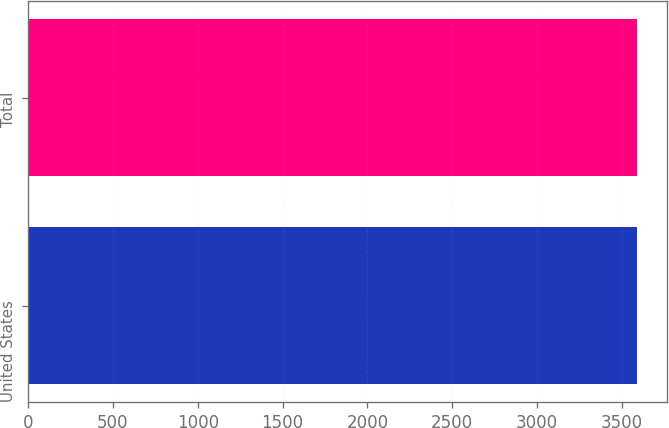Convert chart to OTSL. <chart><loc_0><loc_0><loc_500><loc_500><bar_chart><fcel>United States<fcel>Total<nl><fcel>3588<fcel>3588.1<nl></chart> 